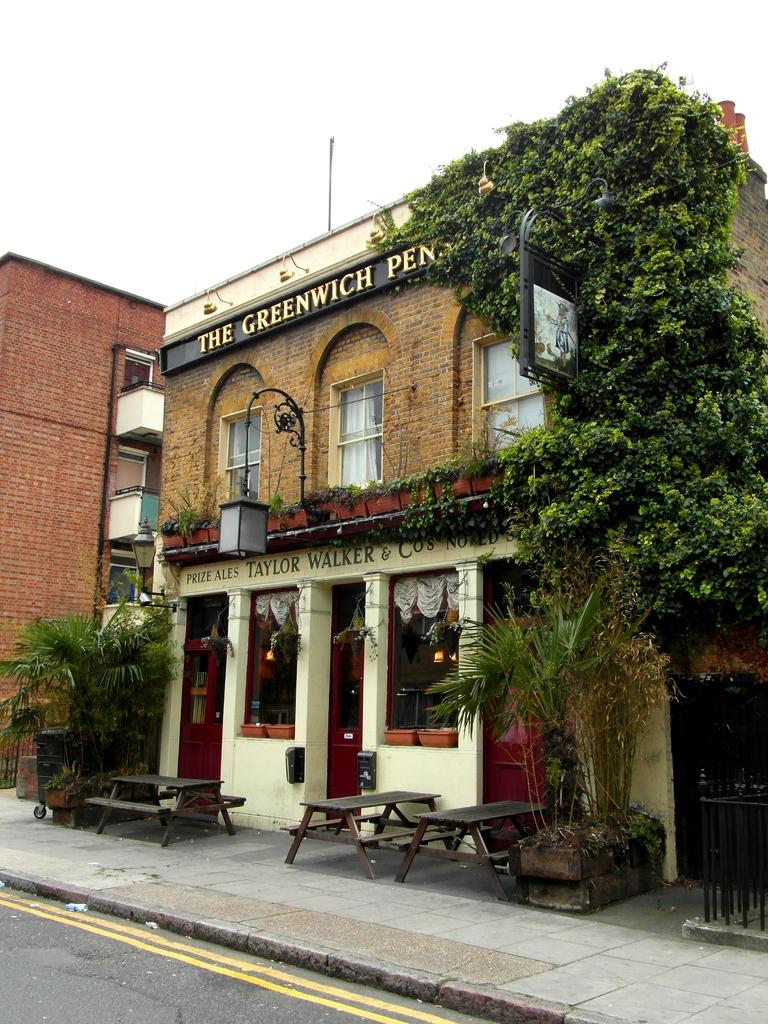What type of structure is visible in the image? There is a building in the image. Where is the building located in relation to the road? The building is in front of a road. What can be seen in front of the building? There are plants and benches in front of the building. What is visible above the building? The sky is visible above the building. How much money is being exchanged between the earth and the slaves in the image? There is no reference to money, earth, or slaves in the image; it features a building, a road, plants, benches, and the sky. 